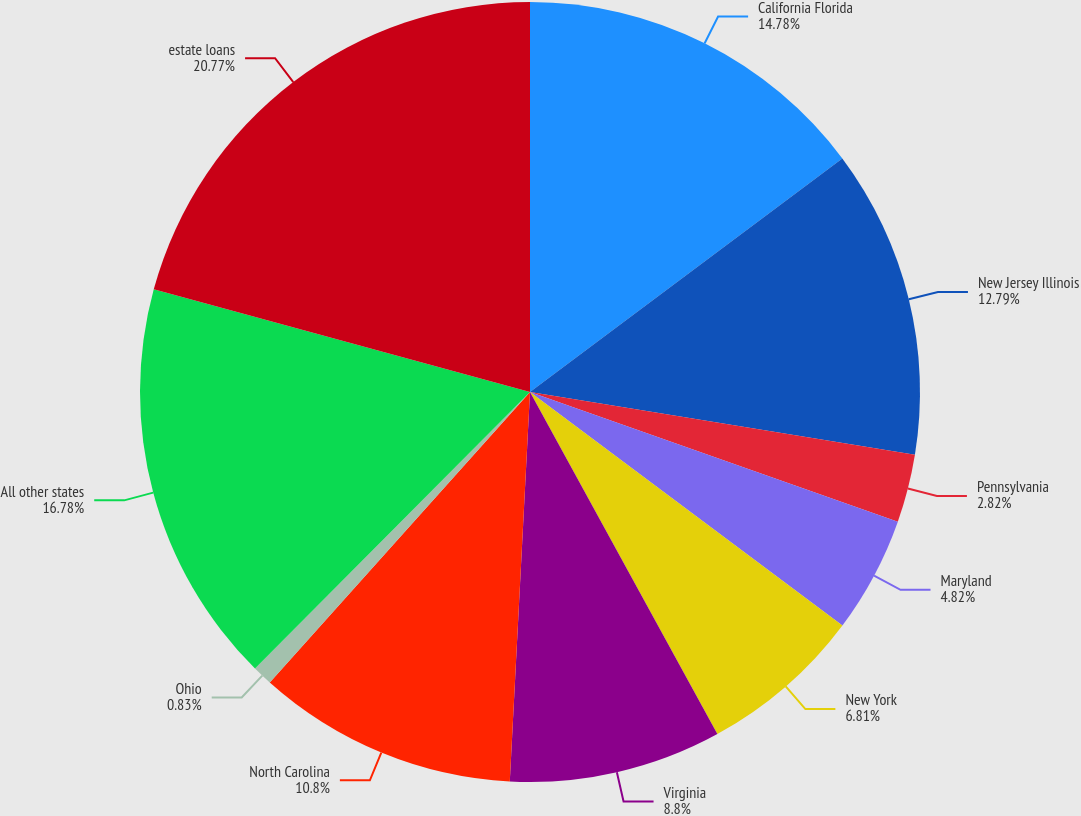Convert chart. <chart><loc_0><loc_0><loc_500><loc_500><pie_chart><fcel>California Florida<fcel>New Jersey Illinois<fcel>Pennsylvania<fcel>Maryland<fcel>New York<fcel>Virginia<fcel>North Carolina<fcel>Ohio<fcel>All other states<fcel>estate loans<nl><fcel>14.78%<fcel>12.79%<fcel>2.82%<fcel>4.82%<fcel>6.81%<fcel>8.8%<fcel>10.8%<fcel>0.83%<fcel>16.78%<fcel>20.76%<nl></chart> 